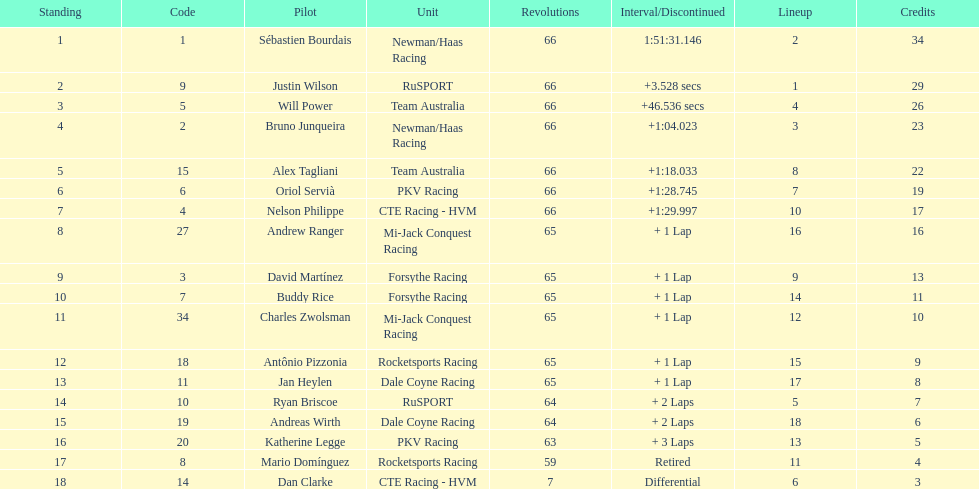Which racer finished just behind the one who had a finishing time of 1:2 Nelson Philippe. Parse the full table. {'header': ['Standing', 'Code', 'Pilot', 'Unit', 'Revolutions', 'Interval/Discontinued', 'Lineup', 'Credits'], 'rows': [['1', '1', 'Sébastien Bourdais', 'Newman/Haas Racing', '66', '1:51:31.146', '2', '34'], ['2', '9', 'Justin Wilson', 'RuSPORT', '66', '+3.528 secs', '1', '29'], ['3', '5', 'Will Power', 'Team Australia', '66', '+46.536 secs', '4', '26'], ['4', '2', 'Bruno Junqueira', 'Newman/Haas Racing', '66', '+1:04.023', '3', '23'], ['5', '15', 'Alex Tagliani', 'Team Australia', '66', '+1:18.033', '8', '22'], ['6', '6', 'Oriol Servià', 'PKV Racing', '66', '+1:28.745', '7', '19'], ['7', '4', 'Nelson Philippe', 'CTE Racing - HVM', '66', '+1:29.997', '10', '17'], ['8', '27', 'Andrew Ranger', 'Mi-Jack Conquest Racing', '65', '+ 1 Lap', '16', '16'], ['9', '3', 'David Martínez', 'Forsythe Racing', '65', '+ 1 Lap', '9', '13'], ['10', '7', 'Buddy Rice', 'Forsythe Racing', '65', '+ 1 Lap', '14', '11'], ['11', '34', 'Charles Zwolsman', 'Mi-Jack Conquest Racing', '65', '+ 1 Lap', '12', '10'], ['12', '18', 'Antônio Pizzonia', 'Rocketsports Racing', '65', '+ 1 Lap', '15', '9'], ['13', '11', 'Jan Heylen', 'Dale Coyne Racing', '65', '+ 1 Lap', '17', '8'], ['14', '10', 'Ryan Briscoe', 'RuSPORT', '64', '+ 2 Laps', '5', '7'], ['15', '19', 'Andreas Wirth', 'Dale Coyne Racing', '64', '+ 2 Laps', '18', '6'], ['16', '20', 'Katherine Legge', 'PKV Racing', '63', '+ 3 Laps', '13', '5'], ['17', '8', 'Mario Domínguez', 'Rocketsports Racing', '59', 'Retired', '11', '4'], ['18', '14', 'Dan Clarke', 'CTE Racing - HVM', '7', 'Differential', '6', '3']]} 